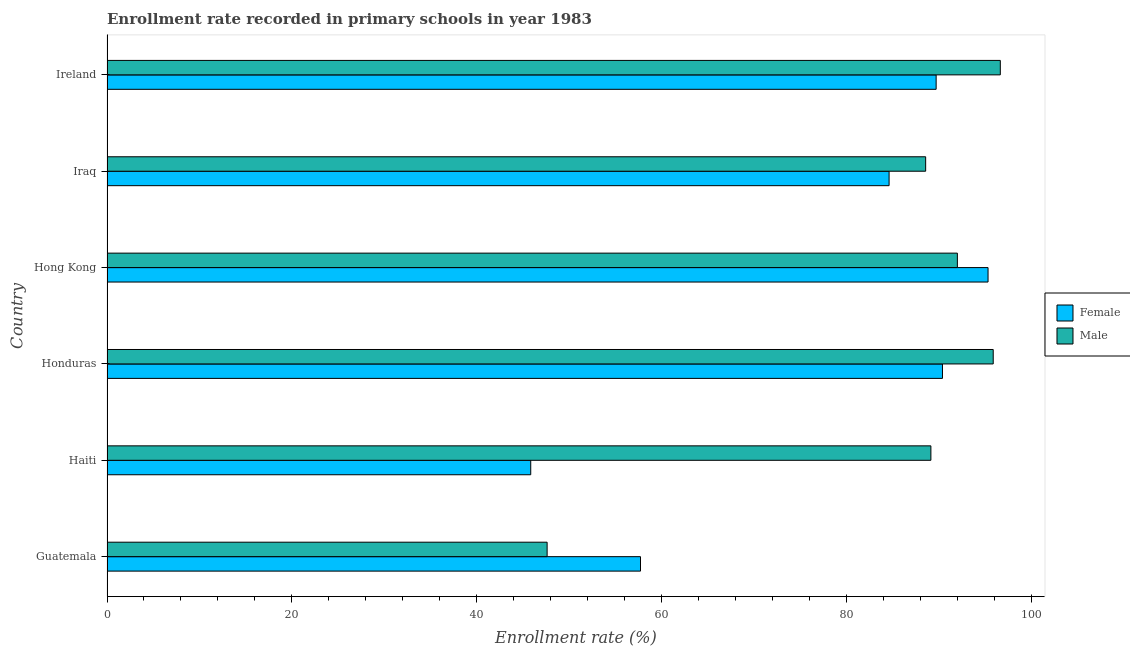How many different coloured bars are there?
Your answer should be very brief. 2. Are the number of bars per tick equal to the number of legend labels?
Provide a short and direct response. Yes. Are the number of bars on each tick of the Y-axis equal?
Provide a short and direct response. Yes. How many bars are there on the 5th tick from the top?
Your response must be concise. 2. What is the label of the 6th group of bars from the top?
Your response must be concise. Guatemala. What is the enrollment rate of female students in Iraq?
Keep it short and to the point. 84.61. Across all countries, what is the maximum enrollment rate of female students?
Your response must be concise. 95.32. Across all countries, what is the minimum enrollment rate of male students?
Offer a very short reply. 47.62. In which country was the enrollment rate of female students maximum?
Make the answer very short. Hong Kong. In which country was the enrollment rate of female students minimum?
Ensure brevity in your answer.  Haiti. What is the total enrollment rate of male students in the graph?
Keep it short and to the point. 509.85. What is the difference between the enrollment rate of female students in Hong Kong and that in Iraq?
Your answer should be very brief. 10.71. What is the difference between the enrollment rate of male students in Haiti and the enrollment rate of female students in Iraq?
Your response must be concise. 4.52. What is the average enrollment rate of male students per country?
Offer a very short reply. 84.97. What is the difference between the enrollment rate of male students and enrollment rate of female students in Haiti?
Give a very brief answer. 43.29. In how many countries, is the enrollment rate of male students greater than 64 %?
Ensure brevity in your answer.  5. What is the ratio of the enrollment rate of female students in Honduras to that in Ireland?
Offer a terse response. 1.01. Is the enrollment rate of male students in Honduras less than that in Iraq?
Provide a succinct answer. No. What is the difference between the highest and the second highest enrollment rate of male students?
Your response must be concise. 0.77. What is the difference between the highest and the lowest enrollment rate of female students?
Your answer should be very brief. 49.48. Is the sum of the enrollment rate of female students in Honduras and Ireland greater than the maximum enrollment rate of male students across all countries?
Your answer should be compact. Yes. What does the 2nd bar from the top in Iraq represents?
Your answer should be very brief. Female. Are all the bars in the graph horizontal?
Ensure brevity in your answer.  Yes. Are the values on the major ticks of X-axis written in scientific E-notation?
Make the answer very short. No. Where does the legend appear in the graph?
Provide a short and direct response. Center right. How many legend labels are there?
Your answer should be very brief. 2. How are the legend labels stacked?
Provide a succinct answer. Vertical. What is the title of the graph?
Your answer should be very brief. Enrollment rate recorded in primary schools in year 1983. Does "Netherlands" appear as one of the legend labels in the graph?
Provide a succinct answer. No. What is the label or title of the X-axis?
Give a very brief answer. Enrollment rate (%). What is the label or title of the Y-axis?
Provide a short and direct response. Country. What is the Enrollment rate (%) in Female in Guatemala?
Your response must be concise. 57.72. What is the Enrollment rate (%) of Male in Guatemala?
Offer a terse response. 47.62. What is the Enrollment rate (%) in Female in Haiti?
Offer a terse response. 45.84. What is the Enrollment rate (%) in Male in Haiti?
Your answer should be very brief. 89.14. What is the Enrollment rate (%) in Female in Honduras?
Provide a short and direct response. 90.39. What is the Enrollment rate (%) of Male in Honduras?
Keep it short and to the point. 95.88. What is the Enrollment rate (%) of Female in Hong Kong?
Give a very brief answer. 95.32. What is the Enrollment rate (%) of Male in Hong Kong?
Keep it short and to the point. 92. What is the Enrollment rate (%) in Female in Iraq?
Keep it short and to the point. 84.61. What is the Enrollment rate (%) in Male in Iraq?
Offer a terse response. 88.57. What is the Enrollment rate (%) in Female in Ireland?
Offer a terse response. 89.7. What is the Enrollment rate (%) in Male in Ireland?
Make the answer very short. 96.65. Across all countries, what is the maximum Enrollment rate (%) in Female?
Provide a succinct answer. 95.32. Across all countries, what is the maximum Enrollment rate (%) in Male?
Provide a succinct answer. 96.65. Across all countries, what is the minimum Enrollment rate (%) in Female?
Make the answer very short. 45.84. Across all countries, what is the minimum Enrollment rate (%) of Male?
Provide a succinct answer. 47.62. What is the total Enrollment rate (%) in Female in the graph?
Offer a very short reply. 463.59. What is the total Enrollment rate (%) of Male in the graph?
Provide a short and direct response. 509.85. What is the difference between the Enrollment rate (%) of Female in Guatemala and that in Haiti?
Offer a very short reply. 11.88. What is the difference between the Enrollment rate (%) in Male in Guatemala and that in Haiti?
Give a very brief answer. -41.52. What is the difference between the Enrollment rate (%) in Female in Guatemala and that in Honduras?
Provide a succinct answer. -32.67. What is the difference between the Enrollment rate (%) of Male in Guatemala and that in Honduras?
Offer a very short reply. -48.26. What is the difference between the Enrollment rate (%) in Female in Guatemala and that in Hong Kong?
Ensure brevity in your answer.  -37.6. What is the difference between the Enrollment rate (%) in Male in Guatemala and that in Hong Kong?
Your answer should be very brief. -44.38. What is the difference between the Enrollment rate (%) of Female in Guatemala and that in Iraq?
Provide a succinct answer. -26.9. What is the difference between the Enrollment rate (%) of Male in Guatemala and that in Iraq?
Provide a succinct answer. -40.95. What is the difference between the Enrollment rate (%) of Female in Guatemala and that in Ireland?
Ensure brevity in your answer.  -31.99. What is the difference between the Enrollment rate (%) of Male in Guatemala and that in Ireland?
Offer a terse response. -49.03. What is the difference between the Enrollment rate (%) of Female in Haiti and that in Honduras?
Provide a succinct answer. -44.55. What is the difference between the Enrollment rate (%) in Male in Haiti and that in Honduras?
Provide a short and direct response. -6.74. What is the difference between the Enrollment rate (%) in Female in Haiti and that in Hong Kong?
Keep it short and to the point. -49.48. What is the difference between the Enrollment rate (%) of Male in Haiti and that in Hong Kong?
Offer a very short reply. -2.87. What is the difference between the Enrollment rate (%) in Female in Haiti and that in Iraq?
Give a very brief answer. -38.77. What is the difference between the Enrollment rate (%) in Male in Haiti and that in Iraq?
Ensure brevity in your answer.  0.57. What is the difference between the Enrollment rate (%) in Female in Haiti and that in Ireland?
Provide a succinct answer. -43.86. What is the difference between the Enrollment rate (%) of Male in Haiti and that in Ireland?
Offer a terse response. -7.51. What is the difference between the Enrollment rate (%) in Female in Honduras and that in Hong Kong?
Ensure brevity in your answer.  -4.93. What is the difference between the Enrollment rate (%) in Male in Honduras and that in Hong Kong?
Your answer should be compact. 3.88. What is the difference between the Enrollment rate (%) in Female in Honduras and that in Iraq?
Your answer should be very brief. 5.78. What is the difference between the Enrollment rate (%) of Male in Honduras and that in Iraq?
Offer a very short reply. 7.31. What is the difference between the Enrollment rate (%) of Female in Honduras and that in Ireland?
Your answer should be very brief. 0.69. What is the difference between the Enrollment rate (%) in Male in Honduras and that in Ireland?
Keep it short and to the point. -0.77. What is the difference between the Enrollment rate (%) of Female in Hong Kong and that in Iraq?
Your answer should be very brief. 10.71. What is the difference between the Enrollment rate (%) of Male in Hong Kong and that in Iraq?
Provide a succinct answer. 3.43. What is the difference between the Enrollment rate (%) of Female in Hong Kong and that in Ireland?
Offer a terse response. 5.62. What is the difference between the Enrollment rate (%) of Male in Hong Kong and that in Ireland?
Keep it short and to the point. -4.65. What is the difference between the Enrollment rate (%) in Female in Iraq and that in Ireland?
Provide a short and direct response. -5.09. What is the difference between the Enrollment rate (%) in Male in Iraq and that in Ireland?
Your answer should be compact. -8.08. What is the difference between the Enrollment rate (%) in Female in Guatemala and the Enrollment rate (%) in Male in Haiti?
Provide a succinct answer. -31.42. What is the difference between the Enrollment rate (%) of Female in Guatemala and the Enrollment rate (%) of Male in Honduras?
Provide a short and direct response. -38.16. What is the difference between the Enrollment rate (%) of Female in Guatemala and the Enrollment rate (%) of Male in Hong Kong?
Your response must be concise. -34.28. What is the difference between the Enrollment rate (%) of Female in Guatemala and the Enrollment rate (%) of Male in Iraq?
Ensure brevity in your answer.  -30.85. What is the difference between the Enrollment rate (%) in Female in Guatemala and the Enrollment rate (%) in Male in Ireland?
Your answer should be compact. -38.93. What is the difference between the Enrollment rate (%) in Female in Haiti and the Enrollment rate (%) in Male in Honduras?
Make the answer very short. -50.04. What is the difference between the Enrollment rate (%) of Female in Haiti and the Enrollment rate (%) of Male in Hong Kong?
Offer a terse response. -46.16. What is the difference between the Enrollment rate (%) of Female in Haiti and the Enrollment rate (%) of Male in Iraq?
Offer a terse response. -42.73. What is the difference between the Enrollment rate (%) in Female in Haiti and the Enrollment rate (%) in Male in Ireland?
Make the answer very short. -50.8. What is the difference between the Enrollment rate (%) of Female in Honduras and the Enrollment rate (%) of Male in Hong Kong?
Provide a succinct answer. -1.61. What is the difference between the Enrollment rate (%) in Female in Honduras and the Enrollment rate (%) in Male in Iraq?
Your answer should be very brief. 1.82. What is the difference between the Enrollment rate (%) of Female in Honduras and the Enrollment rate (%) of Male in Ireland?
Ensure brevity in your answer.  -6.26. What is the difference between the Enrollment rate (%) of Female in Hong Kong and the Enrollment rate (%) of Male in Iraq?
Provide a succinct answer. 6.75. What is the difference between the Enrollment rate (%) of Female in Hong Kong and the Enrollment rate (%) of Male in Ireland?
Your response must be concise. -1.33. What is the difference between the Enrollment rate (%) of Female in Iraq and the Enrollment rate (%) of Male in Ireland?
Give a very brief answer. -12.03. What is the average Enrollment rate (%) of Female per country?
Your answer should be very brief. 77.26. What is the average Enrollment rate (%) in Male per country?
Provide a succinct answer. 84.97. What is the difference between the Enrollment rate (%) in Female and Enrollment rate (%) in Male in Guatemala?
Offer a terse response. 10.1. What is the difference between the Enrollment rate (%) in Female and Enrollment rate (%) in Male in Haiti?
Ensure brevity in your answer.  -43.29. What is the difference between the Enrollment rate (%) of Female and Enrollment rate (%) of Male in Honduras?
Give a very brief answer. -5.49. What is the difference between the Enrollment rate (%) of Female and Enrollment rate (%) of Male in Hong Kong?
Offer a very short reply. 3.32. What is the difference between the Enrollment rate (%) of Female and Enrollment rate (%) of Male in Iraq?
Your answer should be compact. -3.96. What is the difference between the Enrollment rate (%) in Female and Enrollment rate (%) in Male in Ireland?
Your response must be concise. -6.94. What is the ratio of the Enrollment rate (%) in Female in Guatemala to that in Haiti?
Make the answer very short. 1.26. What is the ratio of the Enrollment rate (%) in Male in Guatemala to that in Haiti?
Offer a terse response. 0.53. What is the ratio of the Enrollment rate (%) of Female in Guatemala to that in Honduras?
Provide a short and direct response. 0.64. What is the ratio of the Enrollment rate (%) in Male in Guatemala to that in Honduras?
Your response must be concise. 0.5. What is the ratio of the Enrollment rate (%) in Female in Guatemala to that in Hong Kong?
Your response must be concise. 0.61. What is the ratio of the Enrollment rate (%) in Male in Guatemala to that in Hong Kong?
Provide a succinct answer. 0.52. What is the ratio of the Enrollment rate (%) of Female in Guatemala to that in Iraq?
Provide a succinct answer. 0.68. What is the ratio of the Enrollment rate (%) in Male in Guatemala to that in Iraq?
Provide a succinct answer. 0.54. What is the ratio of the Enrollment rate (%) of Female in Guatemala to that in Ireland?
Keep it short and to the point. 0.64. What is the ratio of the Enrollment rate (%) in Male in Guatemala to that in Ireland?
Offer a terse response. 0.49. What is the ratio of the Enrollment rate (%) of Female in Haiti to that in Honduras?
Give a very brief answer. 0.51. What is the ratio of the Enrollment rate (%) in Male in Haiti to that in Honduras?
Offer a terse response. 0.93. What is the ratio of the Enrollment rate (%) of Female in Haiti to that in Hong Kong?
Keep it short and to the point. 0.48. What is the ratio of the Enrollment rate (%) of Male in Haiti to that in Hong Kong?
Make the answer very short. 0.97. What is the ratio of the Enrollment rate (%) of Female in Haiti to that in Iraq?
Give a very brief answer. 0.54. What is the ratio of the Enrollment rate (%) of Male in Haiti to that in Iraq?
Your answer should be very brief. 1.01. What is the ratio of the Enrollment rate (%) of Female in Haiti to that in Ireland?
Offer a terse response. 0.51. What is the ratio of the Enrollment rate (%) of Male in Haiti to that in Ireland?
Offer a terse response. 0.92. What is the ratio of the Enrollment rate (%) of Female in Honduras to that in Hong Kong?
Make the answer very short. 0.95. What is the ratio of the Enrollment rate (%) in Male in Honduras to that in Hong Kong?
Your answer should be compact. 1.04. What is the ratio of the Enrollment rate (%) of Female in Honduras to that in Iraq?
Your answer should be compact. 1.07. What is the ratio of the Enrollment rate (%) in Male in Honduras to that in Iraq?
Your response must be concise. 1.08. What is the ratio of the Enrollment rate (%) in Female in Honduras to that in Ireland?
Offer a terse response. 1.01. What is the ratio of the Enrollment rate (%) of Male in Honduras to that in Ireland?
Offer a very short reply. 0.99. What is the ratio of the Enrollment rate (%) of Female in Hong Kong to that in Iraq?
Ensure brevity in your answer.  1.13. What is the ratio of the Enrollment rate (%) in Male in Hong Kong to that in Iraq?
Give a very brief answer. 1.04. What is the ratio of the Enrollment rate (%) in Female in Hong Kong to that in Ireland?
Provide a succinct answer. 1.06. What is the ratio of the Enrollment rate (%) of Male in Hong Kong to that in Ireland?
Make the answer very short. 0.95. What is the ratio of the Enrollment rate (%) of Female in Iraq to that in Ireland?
Keep it short and to the point. 0.94. What is the ratio of the Enrollment rate (%) of Male in Iraq to that in Ireland?
Your answer should be compact. 0.92. What is the difference between the highest and the second highest Enrollment rate (%) of Female?
Provide a short and direct response. 4.93. What is the difference between the highest and the second highest Enrollment rate (%) of Male?
Ensure brevity in your answer.  0.77. What is the difference between the highest and the lowest Enrollment rate (%) of Female?
Provide a short and direct response. 49.48. What is the difference between the highest and the lowest Enrollment rate (%) of Male?
Keep it short and to the point. 49.03. 